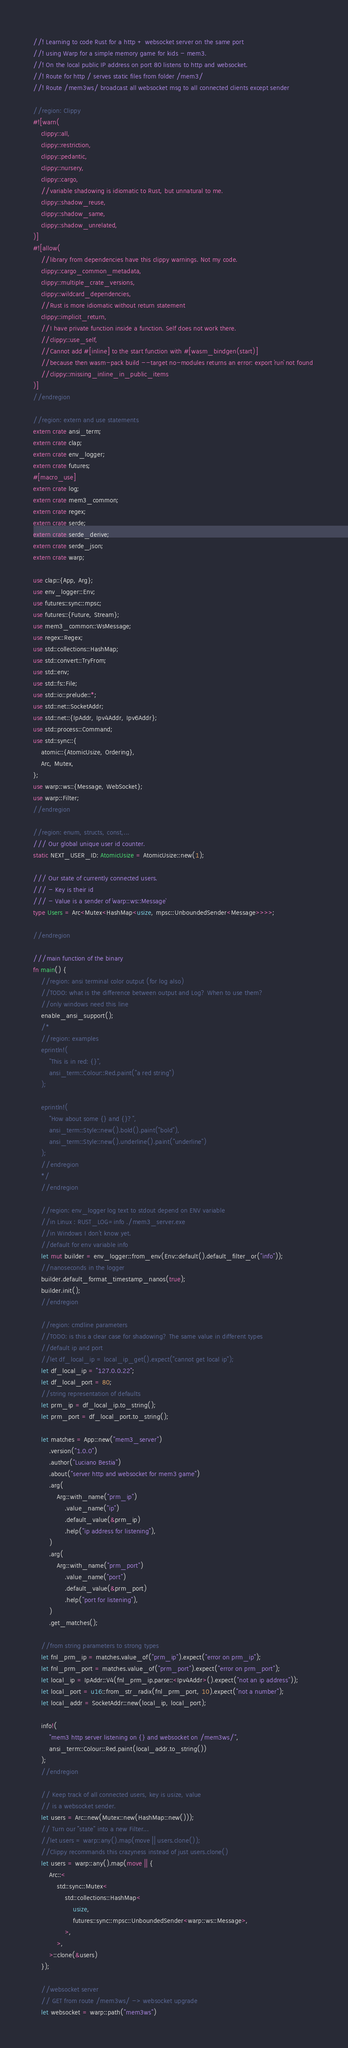<code> <loc_0><loc_0><loc_500><loc_500><_Rust_>//! Learning to code Rust for a http + websocket server on the same port  
//! using Warp for a simple memory game for kids - mem3.
//! On the local public IP address on port 80 listens to http and websocket.
//! Route for http / serves static files from folder /mem3/
//! Route /mem3ws/ broadcast all websocket msg to all connected clients except sender

//region: Clippy
#![warn(
    clippy::all,
    clippy::restriction,
    clippy::pedantic,
    clippy::nursery,
    clippy::cargo,
    //variable shadowing is idiomatic to Rust, but unnatural to me.
    clippy::shadow_reuse,
    clippy::shadow_same,
    clippy::shadow_unrelated,
)]
#![allow(
    //library from dependencies have this clippy warnings. Not my code.
    clippy::cargo_common_metadata,
    clippy::multiple_crate_versions,
    clippy::wildcard_dependencies,
    //Rust is more idiomatic without return statement
    clippy::implicit_return,
    //I have private function inside a function. Self does not work there.
    //clippy::use_self,
    //Cannot add #[inline] to the start function with #[wasm_bindgen(start)]
    //because then wasm-pack build --target no-modules returns an error: export `run` not found 
    //clippy::missing_inline_in_public_items
)]
//endregion

//region: extern and use statements
extern crate ansi_term;
extern crate clap;
extern crate env_logger;
extern crate futures;
#[macro_use]
extern crate log;
extern crate mem3_common;
extern crate regex;
extern crate serde;
extern crate serde_derive;
extern crate serde_json;
extern crate warp;

use clap::{App, Arg};
use env_logger::Env;
use futures::sync::mpsc;
use futures::{Future, Stream};
use mem3_common::WsMessage;
use regex::Regex;
use std::collections::HashMap;
use std::convert::TryFrom;
use std::env;
use std::fs::File;
use std::io::prelude::*;
use std::net::SocketAddr;
use std::net::{IpAddr, Ipv4Addr, Ipv6Addr};
use std::process::Command;
use std::sync::{
    atomic::{AtomicUsize, Ordering},
    Arc, Mutex,
};
use warp::ws::{Message, WebSocket};
use warp::Filter;
//endregion

//region: enum, structs, const,...
/// Our global unique user id counter.
static NEXT_USER_ID: AtomicUsize = AtomicUsize::new(1);

/// Our state of currently connected users.
/// - Key is their id
/// - Value is a sender of `warp::ws::Message`
type Users = Arc<Mutex<HashMap<usize, mpsc::UnboundedSender<Message>>>>;

//endregion

///main function of the binary
fn main() {
    //region: ansi terminal color output (for log also)
    //TODO: what is the difference between output and Log? When to use them?
    //only windows need this line
    enable_ansi_support();
    /*
    //region: examples
    eprintln!(
        "This is in red: {}",
        ansi_term::Colour::Red.paint("a red string")
    );

    eprintln!(
        "How about some {} and {}?",
        ansi_term::Style::new().bold().paint("bold"),
        ansi_term::Style::new().underline().paint("underline")
    );
    //endregion
    */
    //endregion

    //region: env_logger log text to stdout depend on ENV variable
    //in Linux : RUST_LOG=info ./mem3_server.exe
    //in Windows I don't know yet.
    //default for env variable info
    let mut builder = env_logger::from_env(Env::default().default_filter_or("info"));
    //nanoseconds in the logger
    builder.default_format_timestamp_nanos(true);
    builder.init();
    //endregion

    //region: cmdline parameters
    //TODO: is this a clear case for shadowing? The same value in different types
    //default ip and port
    //let df_local_ip = local_ip_get().expect("cannot get local ip");
    let df_local_ip = "127.0.0.22";
    let df_local_port = 80;
    //string representation of defaults
    let prm_ip = df_local_ip.to_string();
    let prm_port = df_local_port.to_string();

    let matches = App::new("mem3_server")
        .version("1.0.0")
        .author("Luciano Bestia")
        .about("server http and websocket for mem3 game")
        .arg(
            Arg::with_name("prm_ip")
                .value_name("ip")
                .default_value(&prm_ip)
                .help("ip address for listening"),
        )
        .arg(
            Arg::with_name("prm_port")
                .value_name("port")
                .default_value(&prm_port)
                .help("port for listening"),
        )
        .get_matches();

    //from string parameters to strong types
    let fnl_prm_ip = matches.value_of("prm_ip").expect("error on prm_ip");
    let fnl_prm_port = matches.value_of("prm_port").expect("error on prm_port");
    let local_ip = IpAddr::V4(fnl_prm_ip.parse::<Ipv4Addr>().expect("not an ip address"));
    let local_port = u16::from_str_radix(fnl_prm_port, 10).expect("not a number");
    let local_addr = SocketAddr::new(local_ip, local_port);

    info!(
        "mem3 http server listening on {} and websocket on /mem3ws/",
        ansi_term::Colour::Red.paint(local_addr.to_string())
    );
    //endregion

    // Keep track of all connected users, key is usize, value
    // is a websocket sender.
    let users = Arc::new(Mutex::new(HashMap::new()));
    // Turn our "state" into a new Filter...
    //let users = warp::any().map(move || users.clone());
    //Clippy recommands this crazyness instead of just users.clone()
    let users = warp::any().map(move || {
        Arc::<
            std::sync::Mutex<
                std::collections::HashMap<
                    usize,
                    futures::sync::mpsc::UnboundedSender<warp::ws::Message>,
                >,
            >,
        >::clone(&users)
    });

    //websocket server
    // GET from route /mem3ws/ -> websocket upgrade
    let websocket = warp::path("mem3ws")</code> 